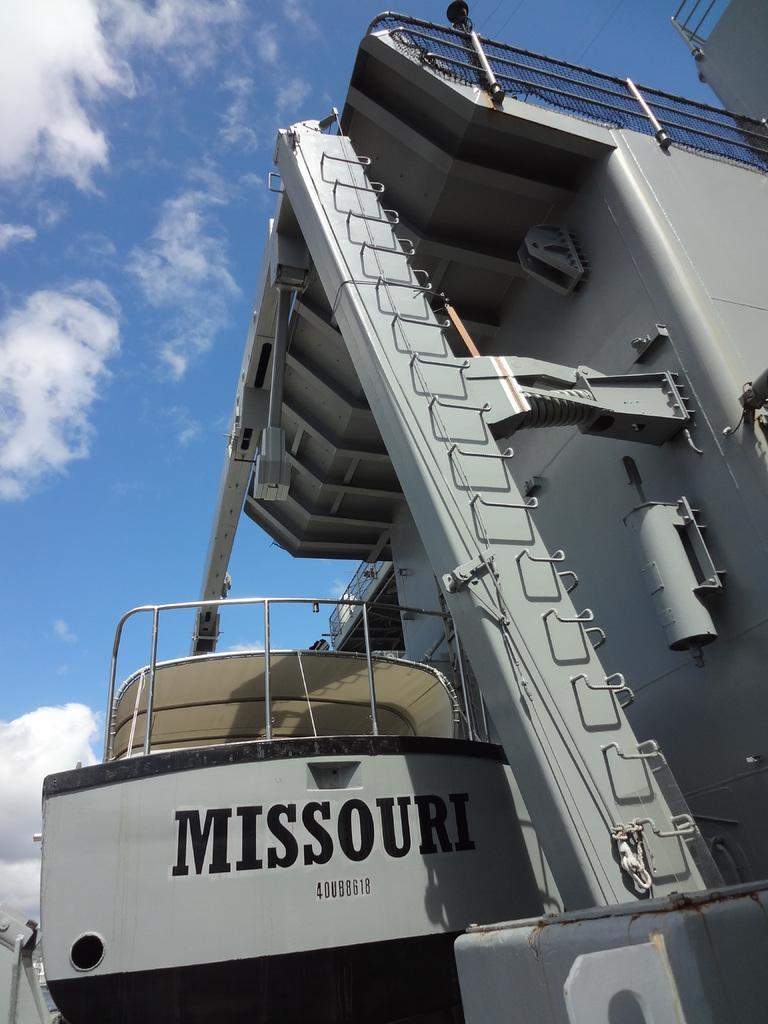What is the main subject of the image? There is a huge ship in the image. What colors are used to depict the ship? The ship is black and grey in color. What can be seen in the background of the image? The sky is visible in the background of the image. Where is the basketball court located in the image? There is no basketball court present in the image; it features a huge ship. What type of road can be seen leading to the prison in the image? There is no prison or road present in the image; it features a huge ship and the sky. 